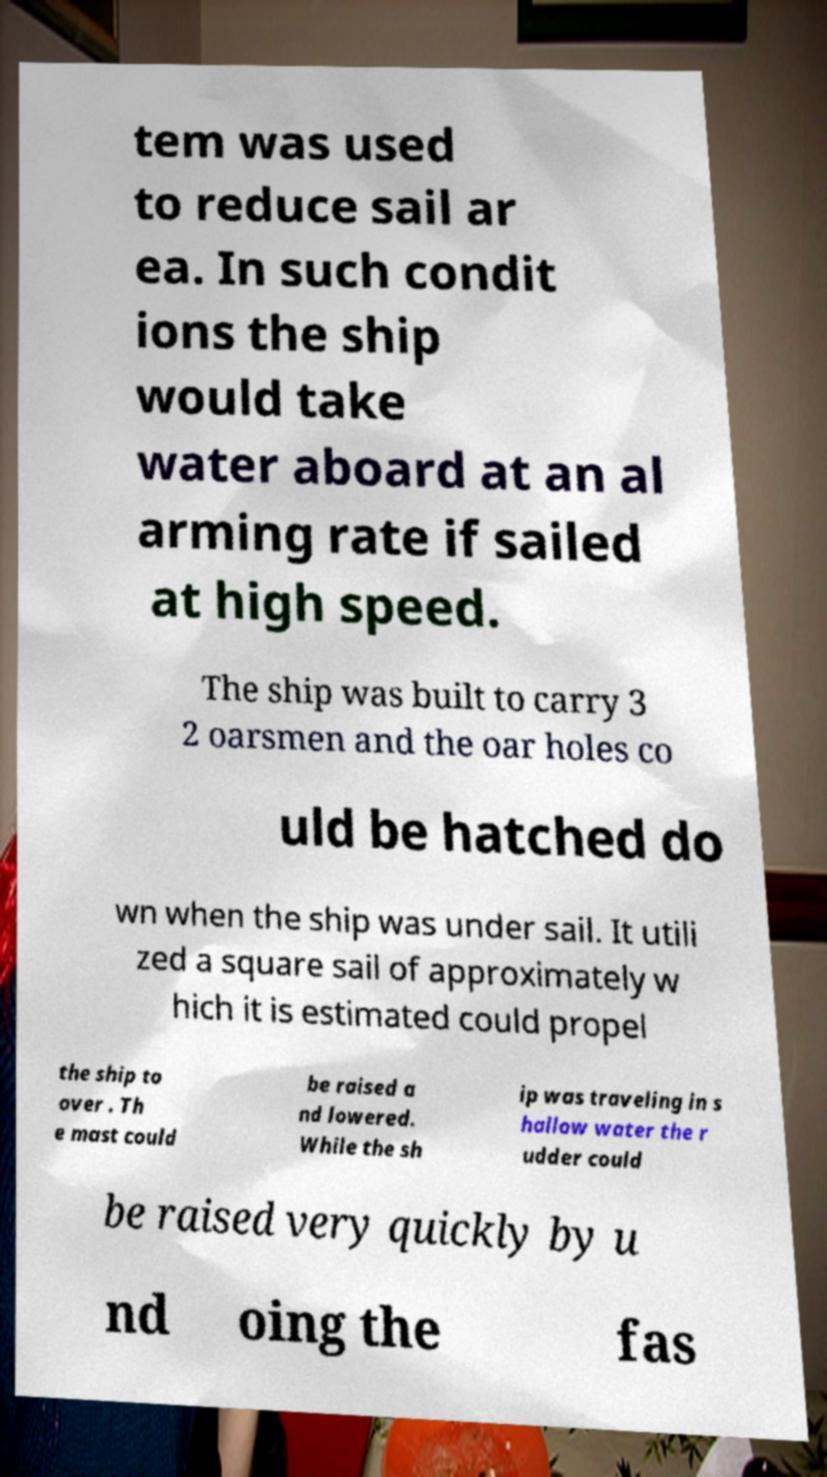Please read and relay the text visible in this image. What does it say? tem was used to reduce sail ar ea. In such condit ions the ship would take water aboard at an al arming rate if sailed at high speed. The ship was built to carry 3 2 oarsmen and the oar holes co uld be hatched do wn when the ship was under sail. It utili zed a square sail of approximately w hich it is estimated could propel the ship to over . Th e mast could be raised a nd lowered. While the sh ip was traveling in s hallow water the r udder could be raised very quickly by u nd oing the fas 